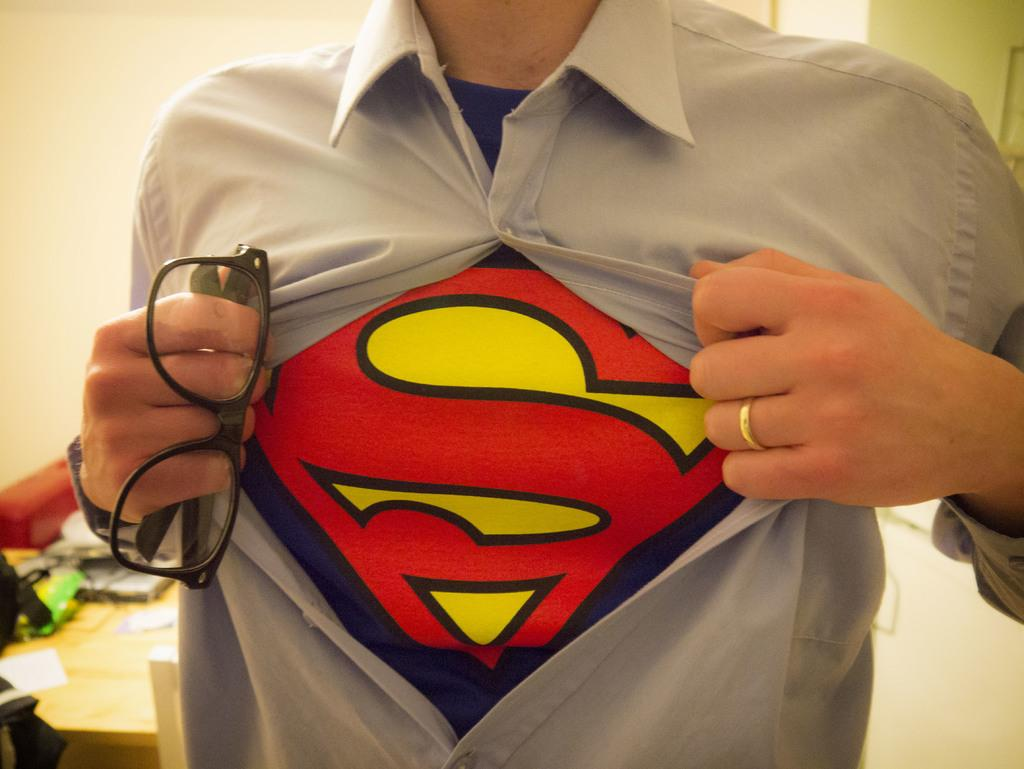Who is present in the image? There is a man in the image. What is the man holding in the image? The man is holding spectacles. What can be seen in the background of the image? There is a table and a wall in the background of the image. What type of dress is the man wearing in the image? The man is not wearing a dress in the image; he is wearing spectacles. What offer is being made by the man in the image? There is no offer being made by the man in the image; he is simply holding spectacles. 